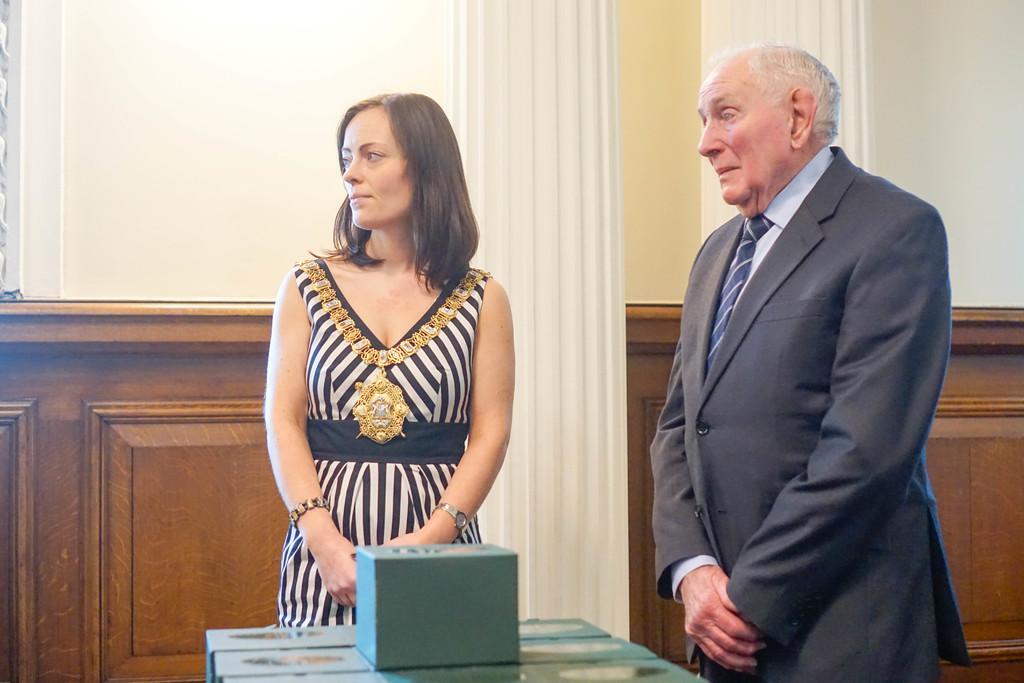How would you summarize this image in a sentence or two? In this image I can see two persons are standing on the floor and some objects. In the background I can see a wall, pillars and wooden fence. This image is taken may be in a hall. 